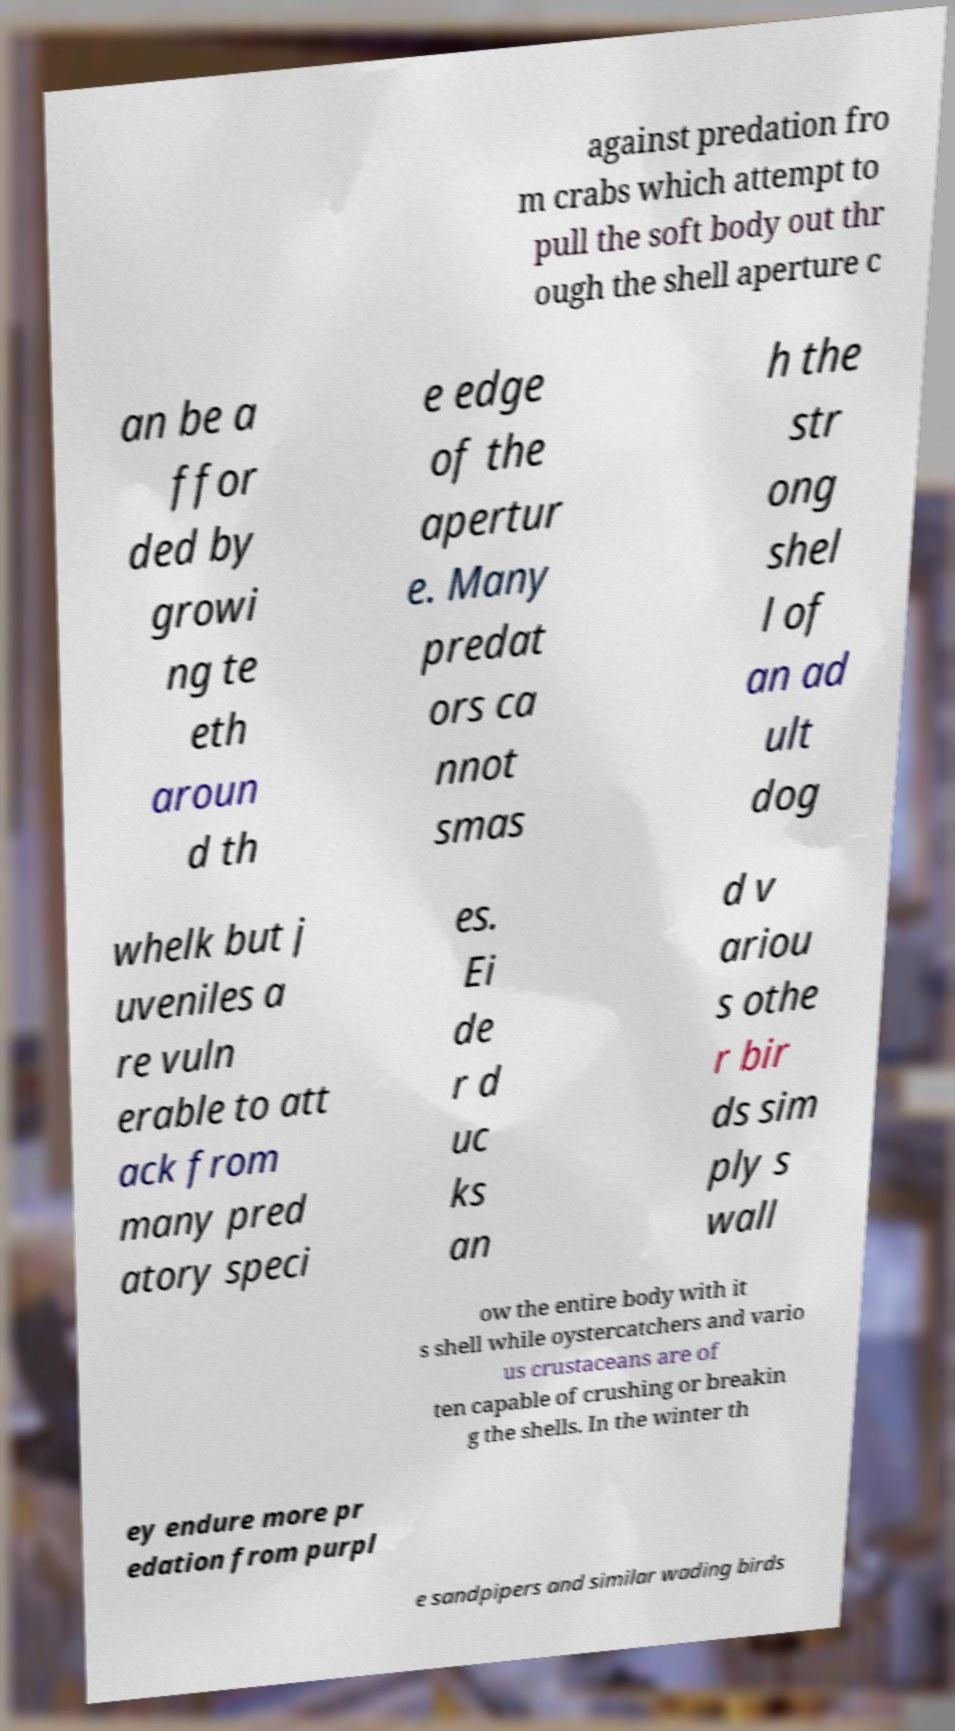Please read and relay the text visible in this image. What does it say? against predation fro m crabs which attempt to pull the soft body out thr ough the shell aperture c an be a ffor ded by growi ng te eth aroun d th e edge of the apertur e. Many predat ors ca nnot smas h the str ong shel l of an ad ult dog whelk but j uveniles a re vuln erable to att ack from many pred atory speci es. Ei de r d uc ks an d v ariou s othe r bir ds sim ply s wall ow the entire body with it s shell while oystercatchers and vario us crustaceans are of ten capable of crushing or breakin g the shells. In the winter th ey endure more pr edation from purpl e sandpipers and similar wading birds 